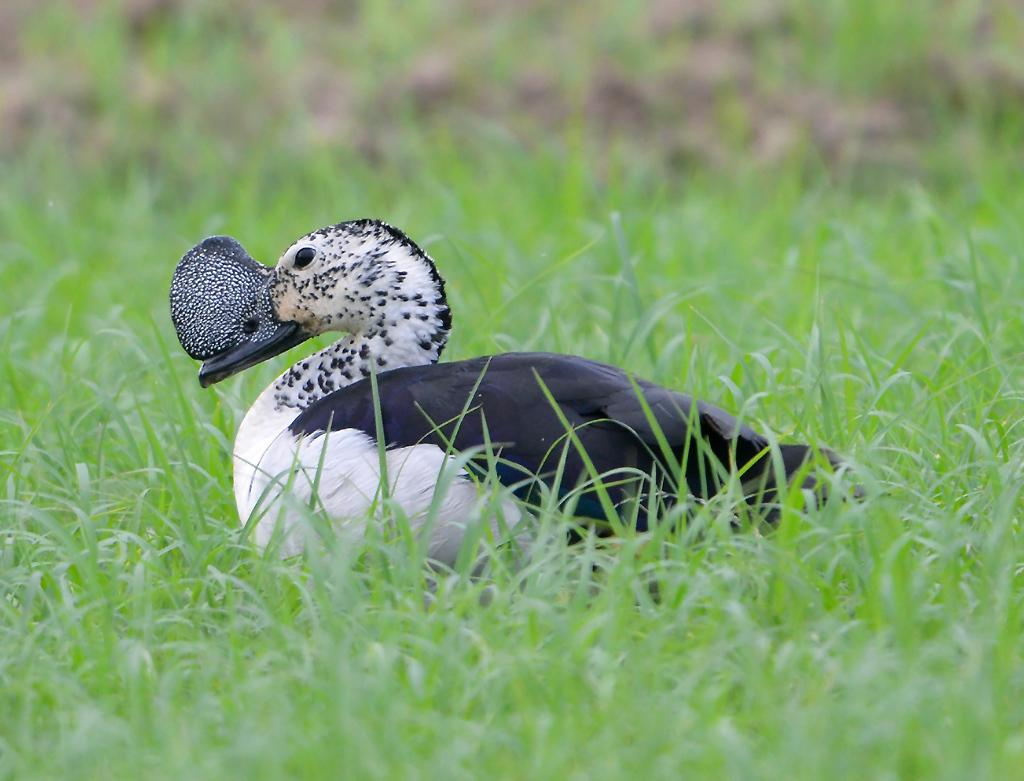What type of bird is in the image? There is a Knob-billed duck in the image. Where is the duck located in the image? The duck is on the ground. What type of vegetation is on the ground in the image? There is green grass on the ground in the image. What type of spark can be seen coming from the duck's beak in the image? There is no spark coming from the duck's beak in the image. 